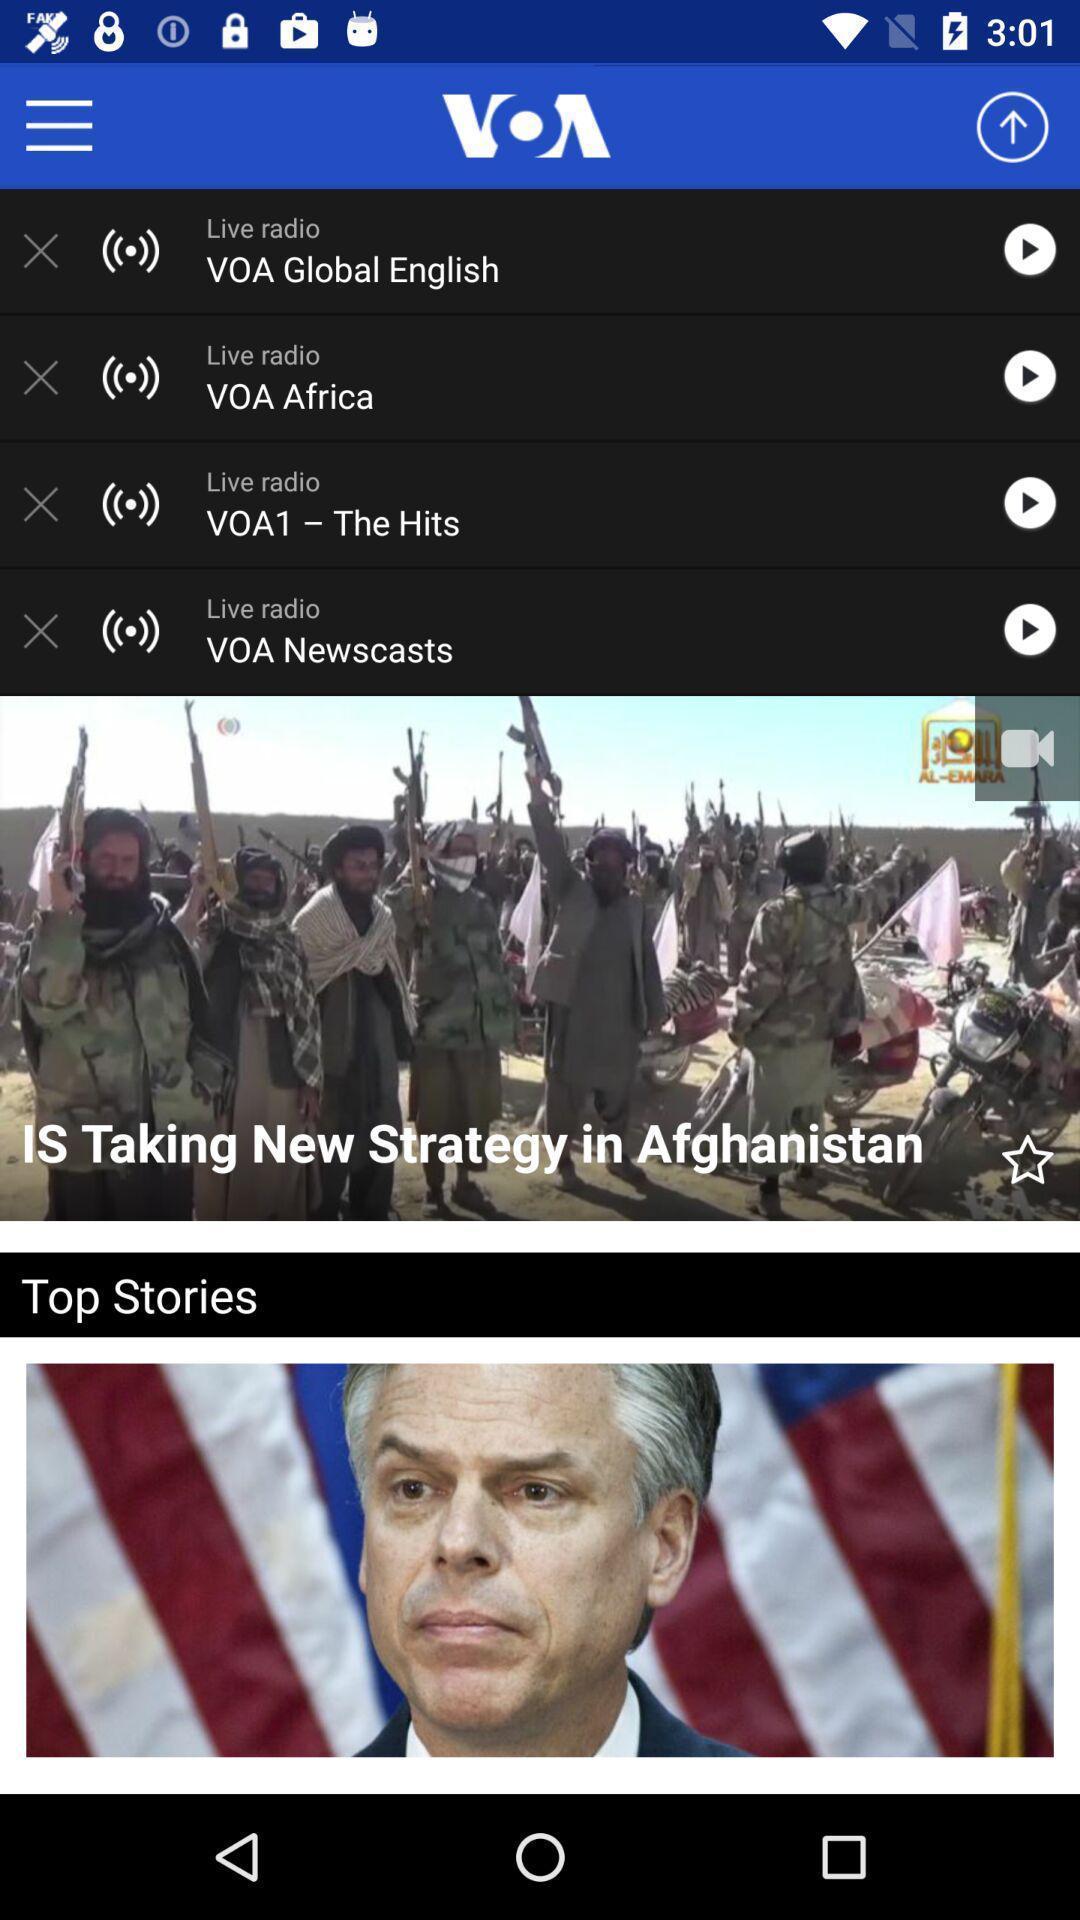Describe the visual elements of this screenshot. Screen page displaying various articles in radio application. 